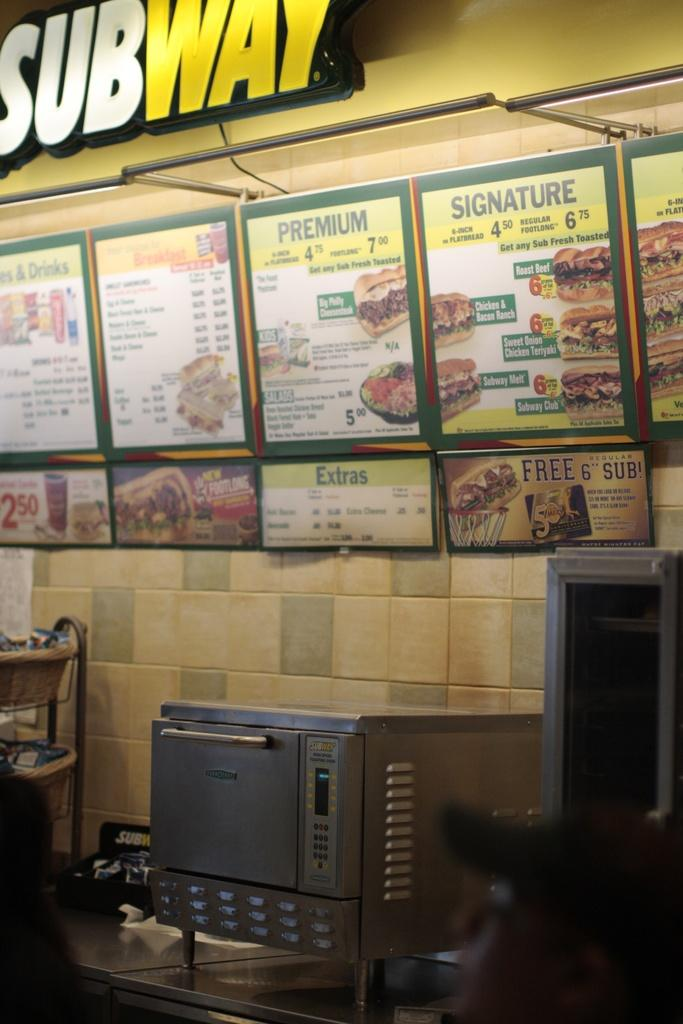Provide a one-sentence caption for the provided image. A sign that says SUBWAY with a menu board underneath it that says Premium and Signature. 